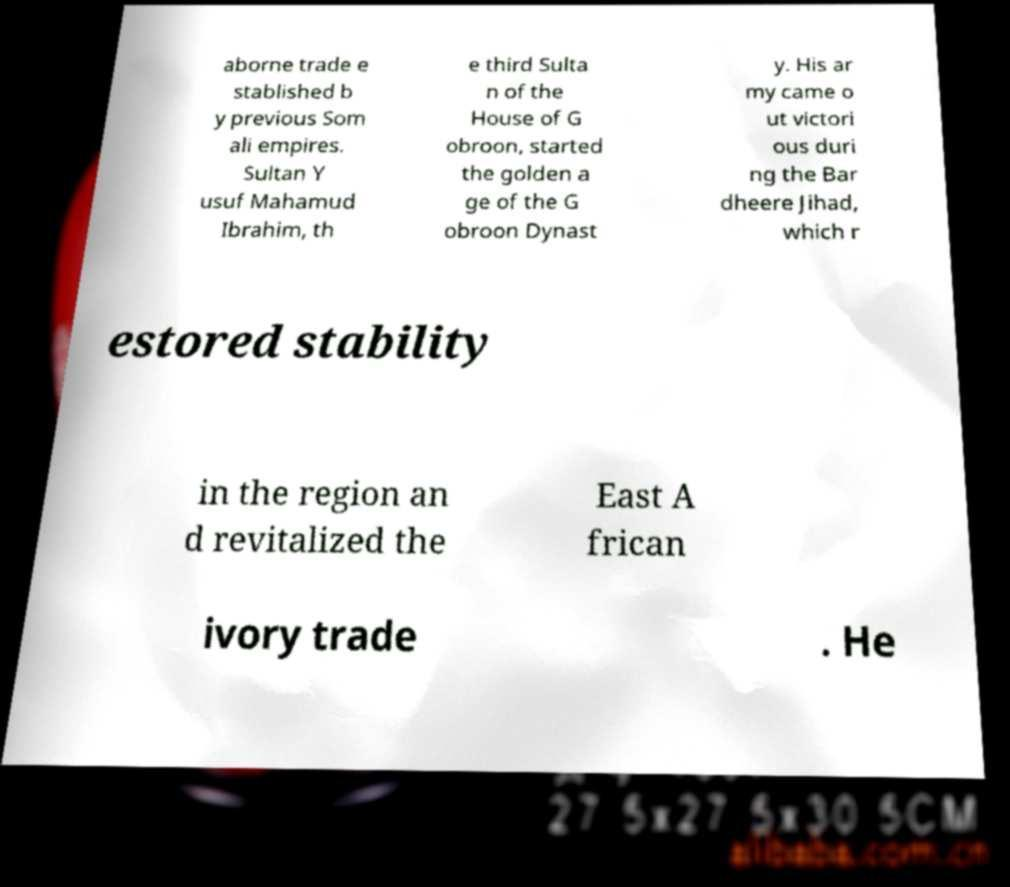Can you read and provide the text displayed in the image?This photo seems to have some interesting text. Can you extract and type it out for me? aborne trade e stablished b y previous Som ali empires. Sultan Y usuf Mahamud Ibrahim, th e third Sulta n of the House of G obroon, started the golden a ge of the G obroon Dynast y. His ar my came o ut victori ous duri ng the Bar dheere Jihad, which r estored stability in the region an d revitalized the East A frican ivory trade . He 